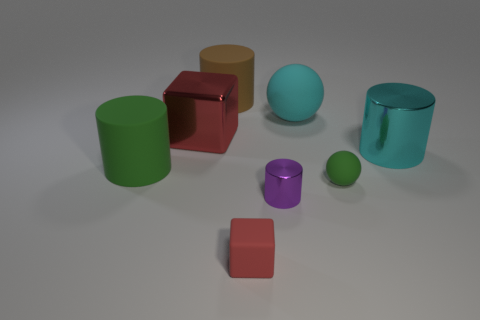How many objects are cylinders, and what are their colors? There are two cylindrical objects in the image. One is a vibrant green, and the other has a glossy teal finish. 